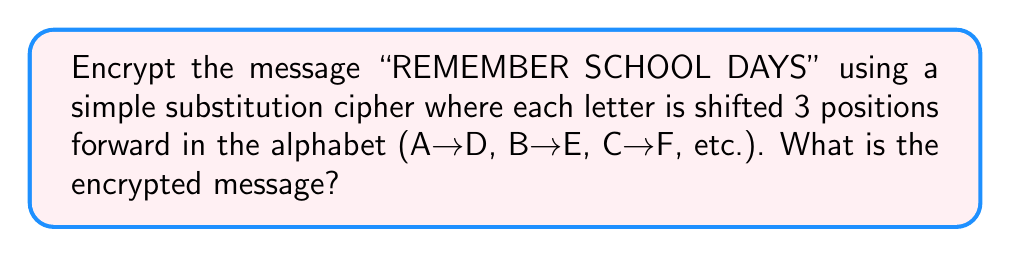Can you answer this question? To encrypt the message using the given simple substitution cipher, we follow these steps:

1. Create a substitution table:
   Plain:    A B C D E F G H I J K L M N O P Q R S T U V W X Y Z
   Cipher:   D E F G H I J K L M N O P Q R S T U V W X Y Z A B C

2. Substitute each letter in the message:
   R → U
   E → H
   M → P
   E → H
   M → P
   B → E
   E → H
   R → U

   S → V
   C → F
   H → K
   O → R
   O → R
   L → O

   D → G
   A → D
   Y → B
   S → V

3. Combine the substituted letters to form the encrypted message.

Note: Spaces are typically removed in simple substitution ciphers, but we'll keep them for readability in this case.
Answer: UHPHPEHU VFKRRO GDBV 